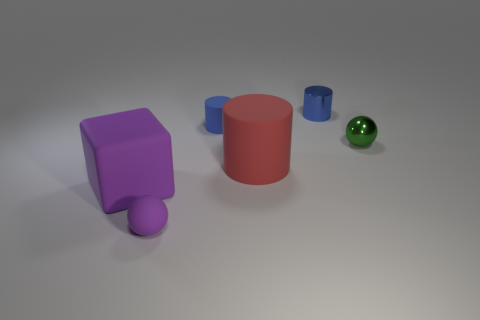Are there the same number of red cylinders that are behind the tiny metallic cylinder and large green cubes?
Keep it short and to the point. Yes. What is the material of the thing that is the same color as the tiny shiny cylinder?
Your answer should be very brief. Rubber. There is a blue rubber thing; is its size the same as the ball that is in front of the tiny shiny ball?
Ensure brevity in your answer.  Yes. How many other things are there of the same size as the green object?
Offer a very short reply. 3. What number of other things are the same color as the tiny matte cylinder?
Provide a short and direct response. 1. Is there anything else that has the same size as the purple cube?
Offer a terse response. Yes. What number of other objects are the same shape as the tiny green thing?
Keep it short and to the point. 1. Does the blue metallic cylinder have the same size as the red rubber object?
Your answer should be very brief. No. Is there a small green block?
Your answer should be very brief. No. Are there any other things that have the same material as the large red object?
Provide a short and direct response. Yes. 